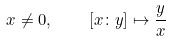<formula> <loc_0><loc_0><loc_500><loc_500>x \neq 0 , \quad [ x \colon y ] \mapsto { \frac { y } { x } }</formula> 